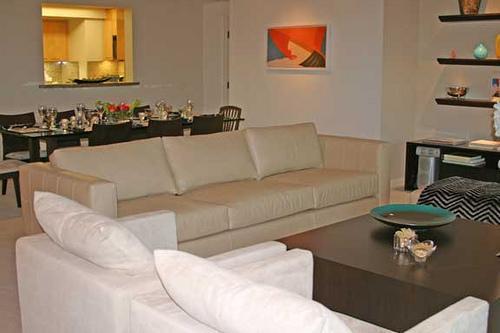How many paintings are on the wall?
Give a very brief answer. 1. How many couches can you see?
Give a very brief answer. 2. 